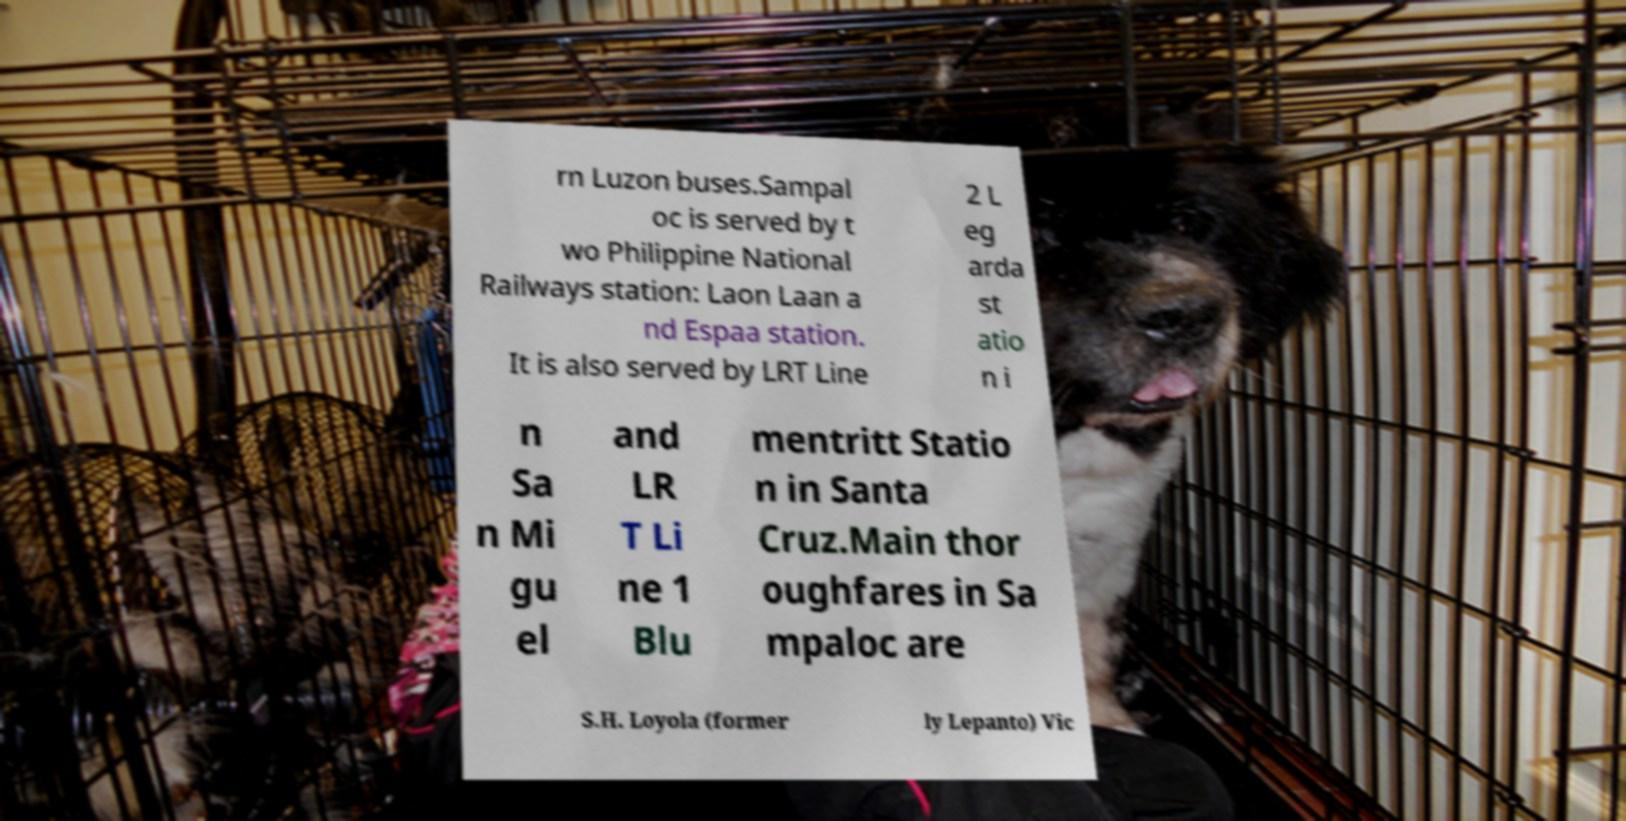I need the written content from this picture converted into text. Can you do that? rn Luzon buses.Sampal oc is served by t wo Philippine National Railways station: Laon Laan a nd Espaa station. It is also served by LRT Line 2 L eg arda st atio n i n Sa n Mi gu el and LR T Li ne 1 Blu mentritt Statio n in Santa Cruz.Main thor oughfares in Sa mpaloc are S.H. Loyola (former ly Lepanto) Vic 